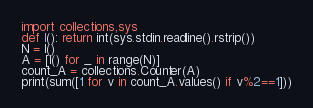Convert code to text. <code><loc_0><loc_0><loc_500><loc_500><_Python_>import collections,sys
def I(): return int(sys.stdin.readline().rstrip())
N = I()
A = [I() for _ in range(N)]
count_A = collections.Counter(A)
print(sum([1 for v in count_A.values() if v%2==1]))
</code> 